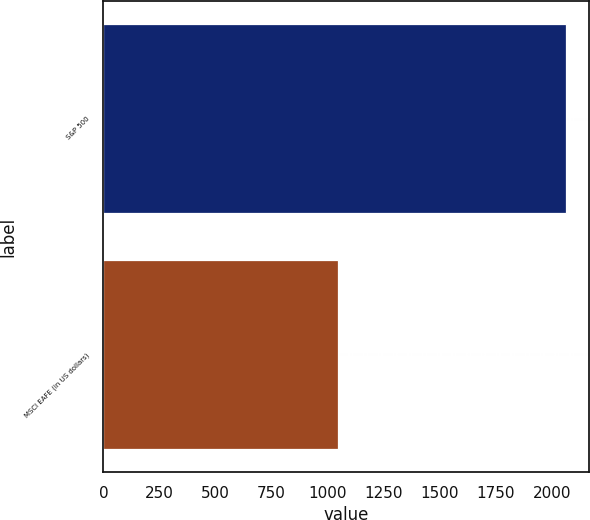Convert chart to OTSL. <chart><loc_0><loc_0><loc_500><loc_500><bar_chart><fcel>S&P 500<fcel>MSCI EAFE (in US dollars)<nl><fcel>2061<fcel>1048<nl></chart> 